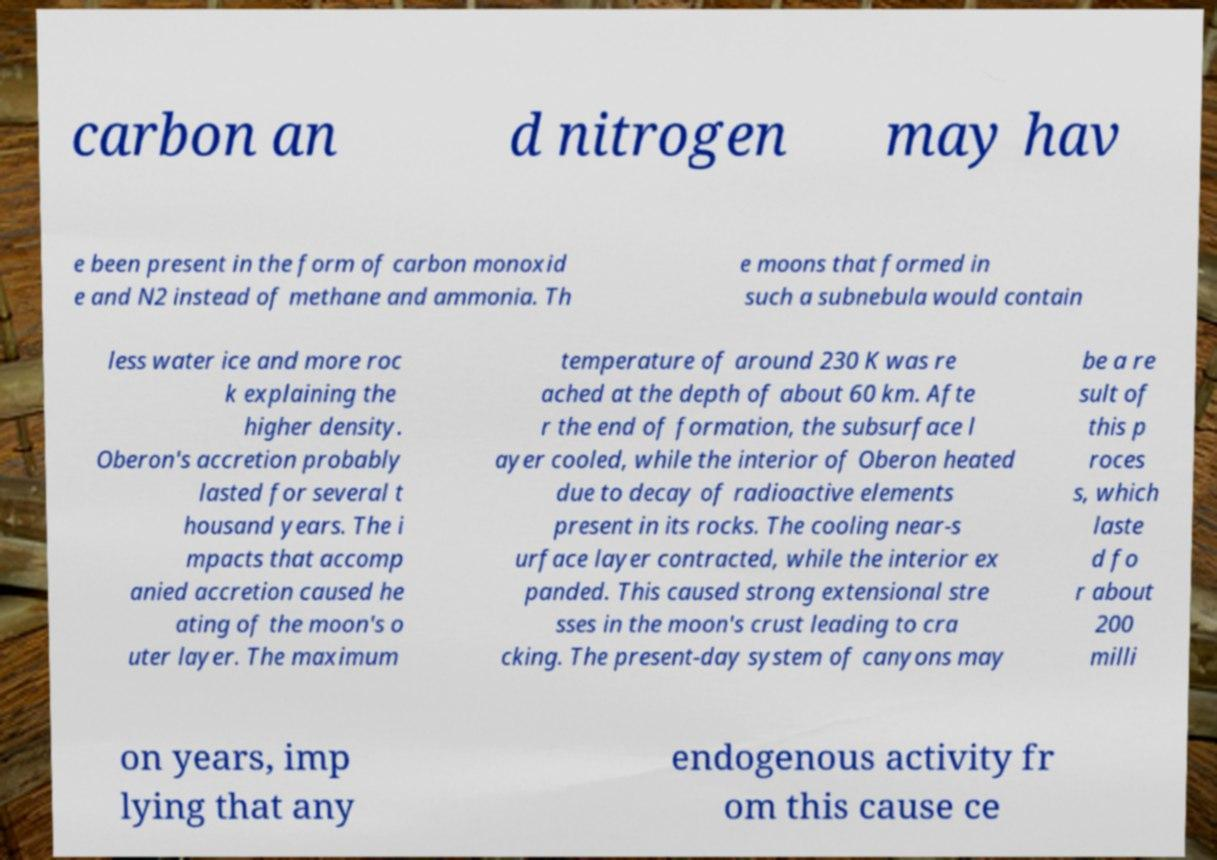Please identify and transcribe the text found in this image. carbon an d nitrogen may hav e been present in the form of carbon monoxid e and N2 instead of methane and ammonia. Th e moons that formed in such a subnebula would contain less water ice and more roc k explaining the higher density. Oberon's accretion probably lasted for several t housand years. The i mpacts that accomp anied accretion caused he ating of the moon's o uter layer. The maximum temperature of around 230 K was re ached at the depth of about 60 km. Afte r the end of formation, the subsurface l ayer cooled, while the interior of Oberon heated due to decay of radioactive elements present in its rocks. The cooling near-s urface layer contracted, while the interior ex panded. This caused strong extensional stre sses in the moon's crust leading to cra cking. The present-day system of canyons may be a re sult of this p roces s, which laste d fo r about 200 milli on years, imp lying that any endogenous activity fr om this cause ce 